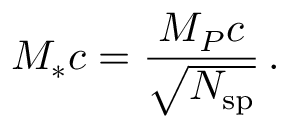Convert formula to latex. <formula><loc_0><loc_0><loc_500><loc_500>M _ { * } c = \frac { M _ { P } c } { \sqrt { N _ { s p } } } \, .</formula> 